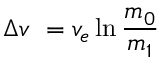Convert formula to latex. <formula><loc_0><loc_0><loc_500><loc_500>\Delta v \ = v _ { e } \ln { \frac { m _ { 0 } } { m _ { 1 } } }</formula> 